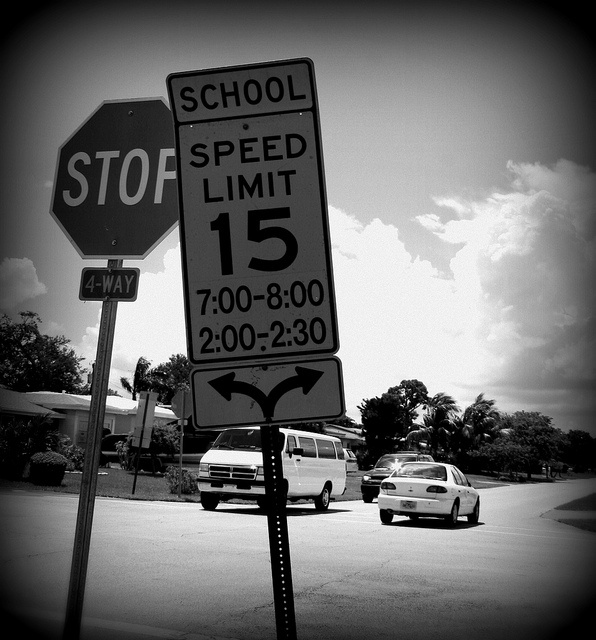Describe the objects in this image and their specific colors. I can see stop sign in black, gray, and lightgray tones, car in black, darkgray, gainsboro, and gray tones, car in black, darkgray, gray, and lightgray tones, truck in black and gray tones, and car in black, darkgray, gray, and lightgray tones in this image. 